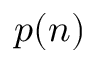<formula> <loc_0><loc_0><loc_500><loc_500>p ( n )</formula> 